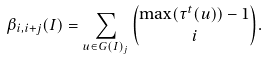<formula> <loc_0><loc_0><loc_500><loc_500>\beta _ { i , i + j } ( I ) = \sum _ { u \in G ( I ) _ { j } } \binom { \max ( \tau ^ { t } ( u ) ) - 1 } { i } .</formula> 